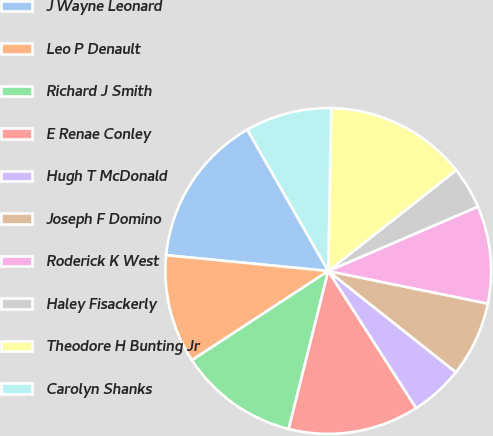Convert chart. <chart><loc_0><loc_0><loc_500><loc_500><pie_chart><fcel>J Wayne Leonard<fcel>Leo P Denault<fcel>Richard J Smith<fcel>E Renae Conley<fcel>Hugh T McDonald<fcel>Joseph F Domino<fcel>Roderick K West<fcel>Haley Fisackerly<fcel>Theodore H Bunting Jr<fcel>Carolyn Shanks<nl><fcel>15.18%<fcel>10.77%<fcel>11.87%<fcel>12.98%<fcel>5.26%<fcel>7.46%<fcel>9.67%<fcel>4.16%<fcel>14.08%<fcel>8.57%<nl></chart> 